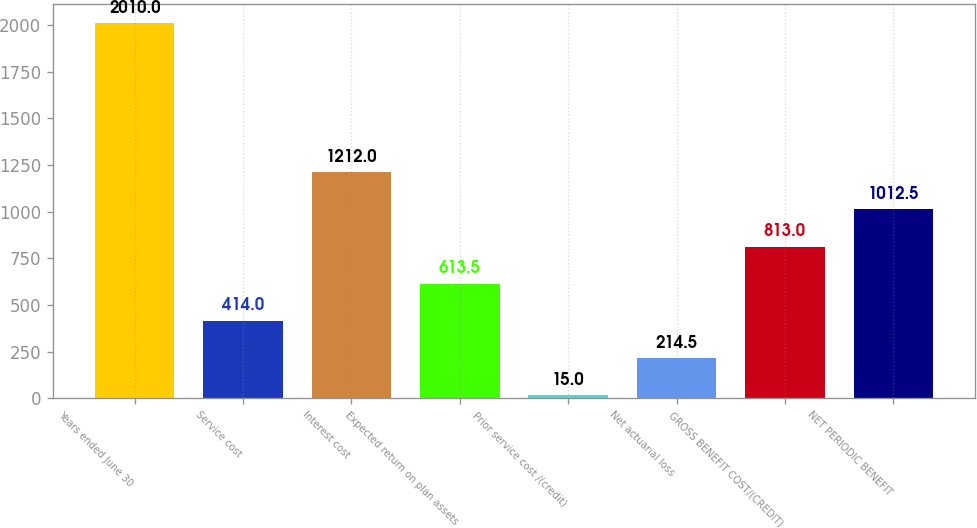Convert chart to OTSL. <chart><loc_0><loc_0><loc_500><loc_500><bar_chart><fcel>Years ended June 30<fcel>Service cost<fcel>Interest cost<fcel>Expected return on plan assets<fcel>Prior service cost /(credit)<fcel>Net actuarial loss<fcel>GROSS BENEFIT COST/(CREDIT)<fcel>NET PERIODIC BENEFIT<nl><fcel>2010<fcel>414<fcel>1212<fcel>613.5<fcel>15<fcel>214.5<fcel>813<fcel>1012.5<nl></chart> 